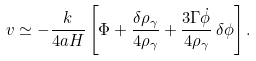Convert formula to latex. <formula><loc_0><loc_0><loc_500><loc_500>v \simeq - \frac { k } { 4 a H } \left [ \Phi + \frac { \delta \rho _ { \gamma } } { 4 \rho _ { \gamma } } + \frac { 3 \Gamma \dot { \phi } } { 4 \rho _ { \gamma } } \, \delta \phi \right ] .</formula> 